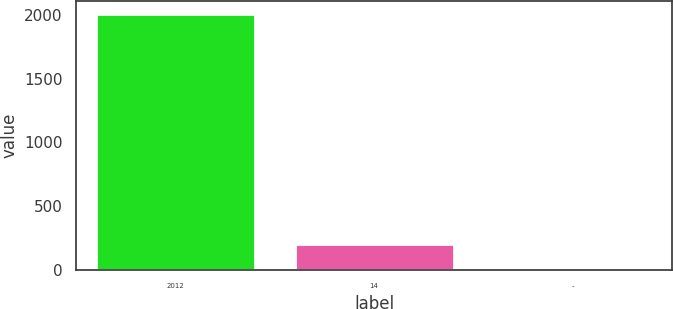<chart> <loc_0><loc_0><loc_500><loc_500><bar_chart><fcel>2012<fcel>14<fcel>-<nl><fcel>2011<fcel>202<fcel>1<nl></chart> 